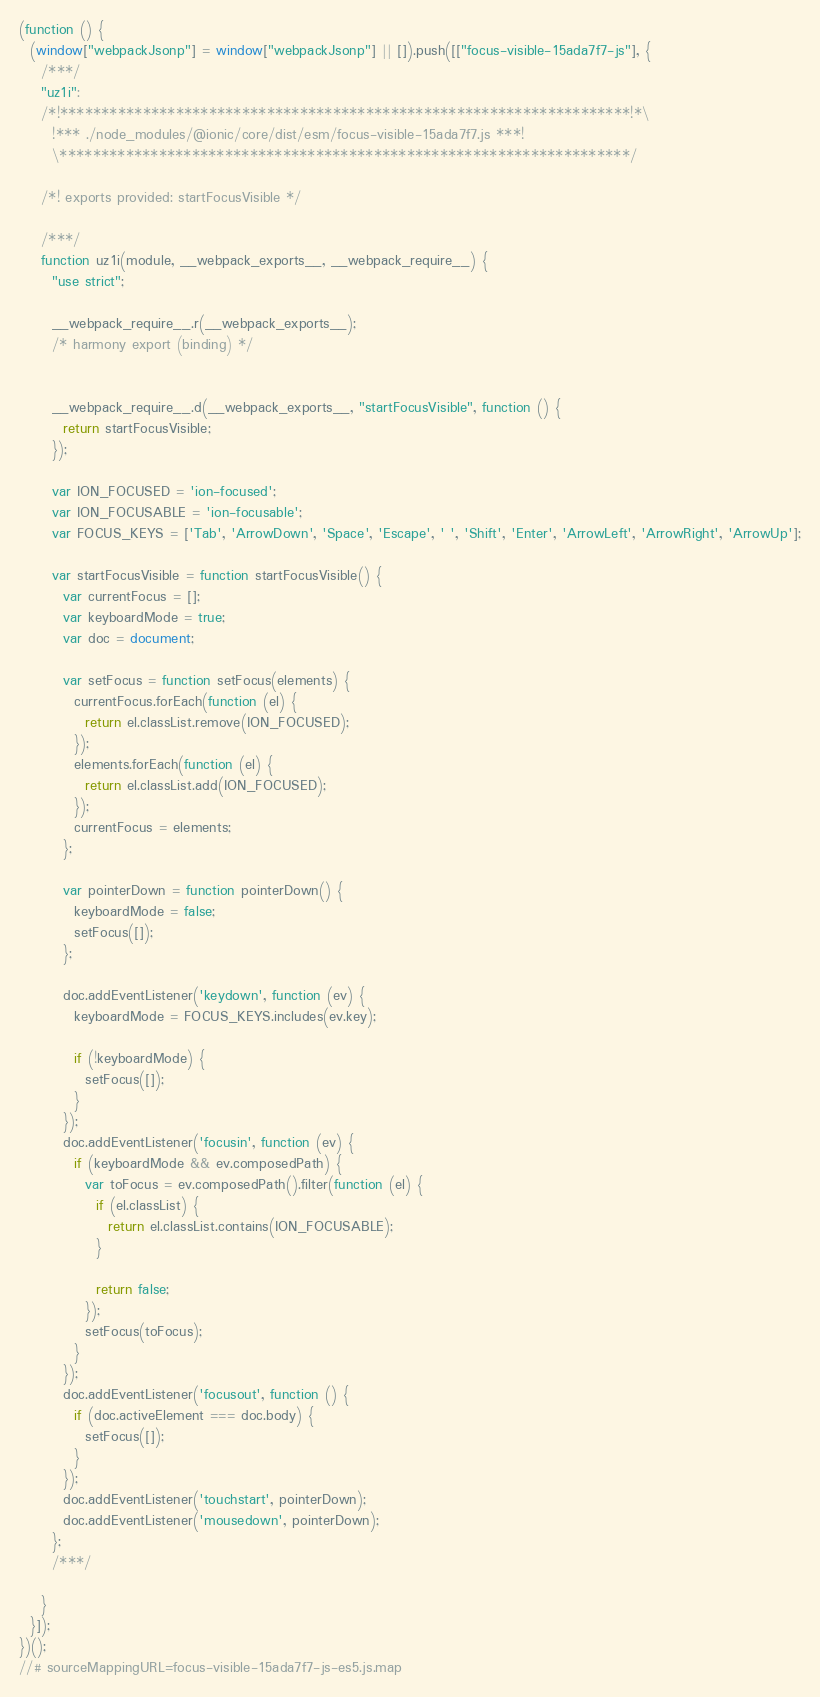<code> <loc_0><loc_0><loc_500><loc_500><_JavaScript_>(function () {
  (window["webpackJsonp"] = window["webpackJsonp"] || []).push([["focus-visible-15ada7f7-js"], {
    /***/
    "uz1i":
    /*!*********************************************************************!*\
      !*** ./node_modules/@ionic/core/dist/esm/focus-visible-15ada7f7.js ***!
      \*********************************************************************/

    /*! exports provided: startFocusVisible */

    /***/
    function uz1i(module, __webpack_exports__, __webpack_require__) {
      "use strict";

      __webpack_require__.r(__webpack_exports__);
      /* harmony export (binding) */


      __webpack_require__.d(__webpack_exports__, "startFocusVisible", function () {
        return startFocusVisible;
      });

      var ION_FOCUSED = 'ion-focused';
      var ION_FOCUSABLE = 'ion-focusable';
      var FOCUS_KEYS = ['Tab', 'ArrowDown', 'Space', 'Escape', ' ', 'Shift', 'Enter', 'ArrowLeft', 'ArrowRight', 'ArrowUp'];

      var startFocusVisible = function startFocusVisible() {
        var currentFocus = [];
        var keyboardMode = true;
        var doc = document;

        var setFocus = function setFocus(elements) {
          currentFocus.forEach(function (el) {
            return el.classList.remove(ION_FOCUSED);
          });
          elements.forEach(function (el) {
            return el.classList.add(ION_FOCUSED);
          });
          currentFocus = elements;
        };

        var pointerDown = function pointerDown() {
          keyboardMode = false;
          setFocus([]);
        };

        doc.addEventListener('keydown', function (ev) {
          keyboardMode = FOCUS_KEYS.includes(ev.key);

          if (!keyboardMode) {
            setFocus([]);
          }
        });
        doc.addEventListener('focusin', function (ev) {
          if (keyboardMode && ev.composedPath) {
            var toFocus = ev.composedPath().filter(function (el) {
              if (el.classList) {
                return el.classList.contains(ION_FOCUSABLE);
              }

              return false;
            });
            setFocus(toFocus);
          }
        });
        doc.addEventListener('focusout', function () {
          if (doc.activeElement === doc.body) {
            setFocus([]);
          }
        });
        doc.addEventListener('touchstart', pointerDown);
        doc.addEventListener('mousedown', pointerDown);
      };
      /***/

    }
  }]);
})();
//# sourceMappingURL=focus-visible-15ada7f7-js-es5.js.map</code> 